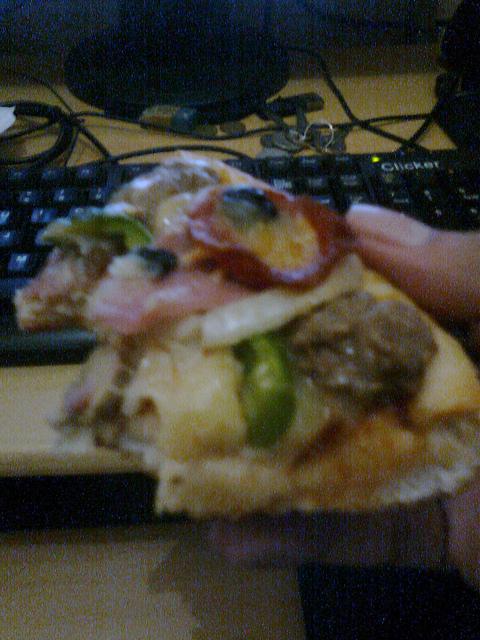Are these vegetarian pizzas?
Answer briefly. No. What color bowls are pictured?
Quick response, please. None. What is in the foreground of the photo?
Short answer required. Pizza. Is the person wearing gloves?
Keep it brief. No. Is this a toast?
Write a very short answer. No. Is it an outdoor scene?
Short answer required. No. Has the pizza been eaten?
Be succinct. Yes. Is this at a restaurant?
Write a very short answer. No. Is this food on a tray?
Short answer required. No. Is the person eating cheese pizza?
Concise answer only. No. Where is the person sitting?
Quick response, please. Desk. What kind of fruit is on the pizza?
Write a very short answer. Pineapple. Has someone eaten the pizza?
Quick response, please. Yes. Is there a glass of wine?
Short answer required. No. Is this a poor quality picture?
Answer briefly. Yes. What kind of food is this?
Write a very short answer. Pizza. Has any of this food been eaten?
Quick response, please. Yes. 